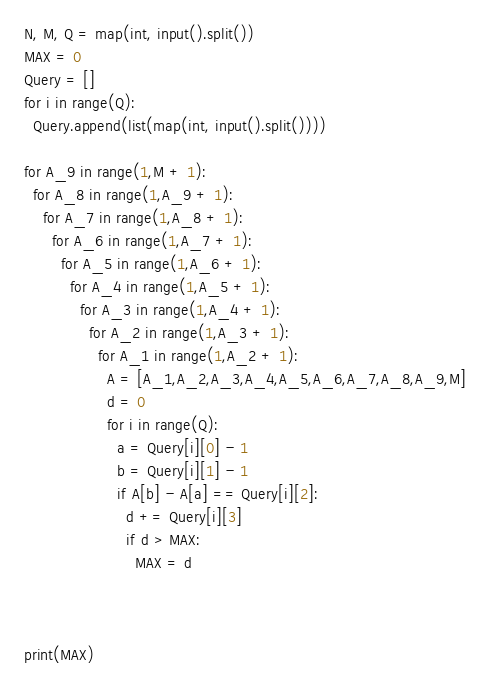<code> <loc_0><loc_0><loc_500><loc_500><_Python_>N, M, Q = map(int, input().split())
MAX = 0
Query = []
for i in range(Q):
  Query.append(list(map(int, input().split())))

for A_9 in range(1,M + 1):
  for A_8 in range(1,A_9 + 1):
    for A_7 in range(1,A_8 + 1):
      for A_6 in range(1,A_7 + 1):
        for A_5 in range(1,A_6 + 1):
          for A_4 in range(1,A_5 + 1):
            for A_3 in range(1,A_4 + 1):
              for A_2 in range(1,A_3 + 1):
                for A_1 in range(1,A_2 + 1):
                  A = [A_1,A_2,A_3,A_4,A_5,A_6,A_7,A_8,A_9,M]
                  d = 0
                  for i in range(Q):
                    a = Query[i][0] - 1
                    b = Query[i][1] - 1
                    if A[b] - A[a] == Query[i][2]:
                      d += Query[i][3]
                      if d > MAX:
                        MAX = d         
      
      
           
print(MAX)</code> 